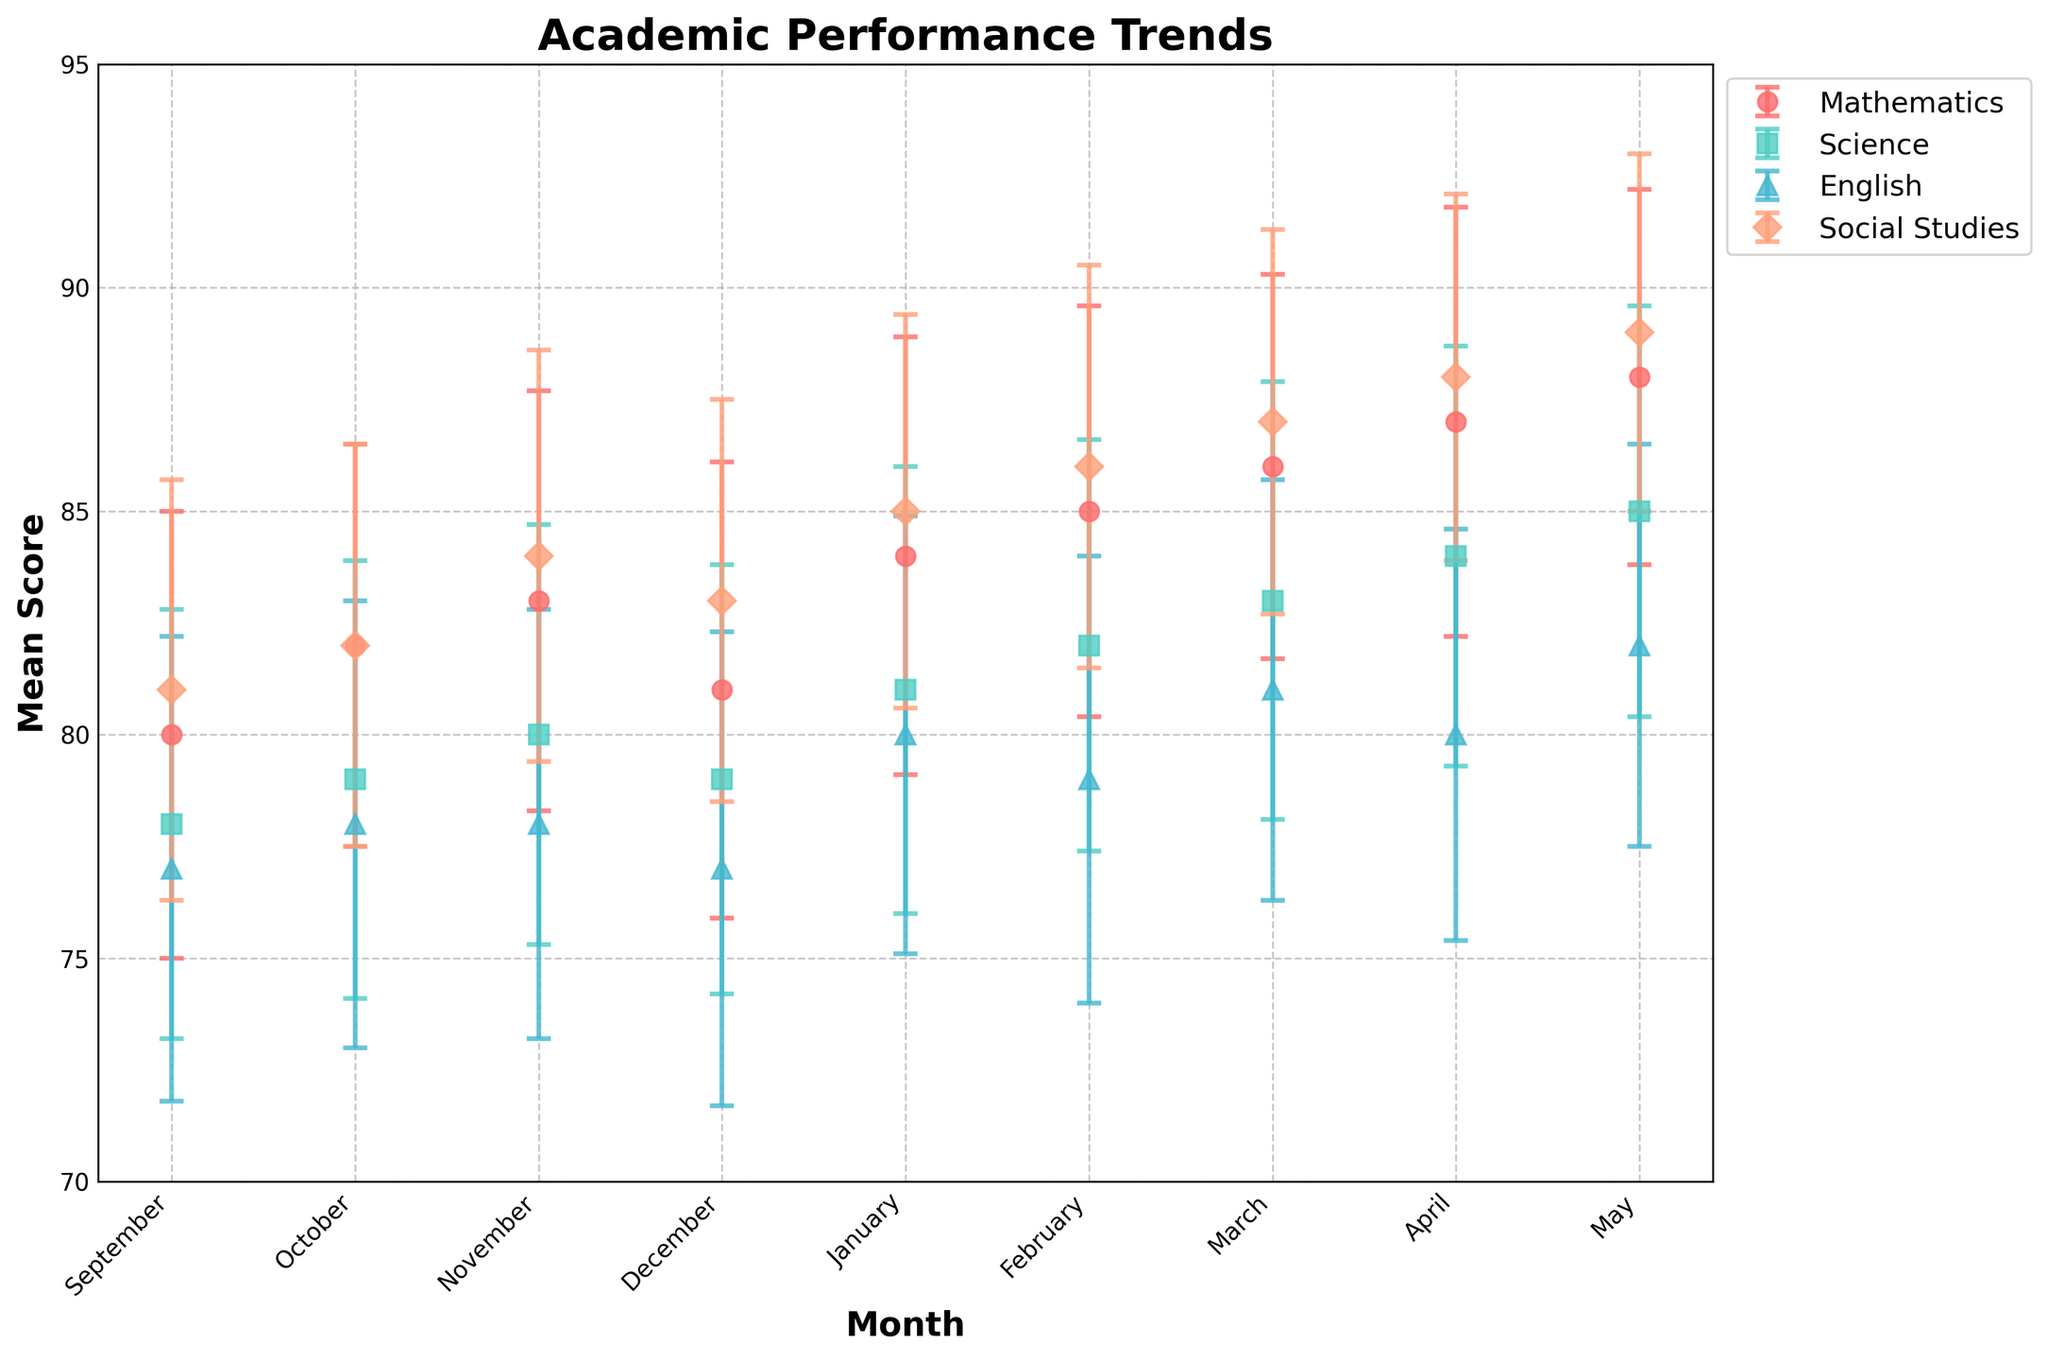What is the main title of the plot? The main title is written at the top center of the plot. It helps in providing an overview of what the plot is about.
Answer: Academic Performance Trends What subjects are represented in the plot? The subjects are shown in the legend of the plot, typically found on the right side of the plot. Each subject is indicated by a different marker and color.
Answer: Mathematics, Science, English, Social Studies In which month does Mathematics have the highest mean score? Look at the Mathematics line in the plot and find the month at which it reaches its peak value.
Answer: May How does the trend of Science scores compare to English scores over the months? Check the lines representing Science and English. Observe the direction and values of these lines across different months.
Answer: Both increase over time with minor variations, but Science consistently has slightly higher scores Which subject has the lowest mean score in September and what is it? Find the data points on the plot for September for each subject and identify the smallest value.
Answer: English, 77 By how much did the Mathematics score increase from January to May? Find the scores of Mathematics for January and May, then subtract the January score from the May score.
Answer: 4 points (88 - 84) During which month do all subjects show their lowest scores? Examine each line's starting point in September to see if any month has the lowest scores across all subjects.
Answer: September Which subject shows the least variability in scores over the year? Observe the lengths of the error bars for each subject; the shorter the error bars, the less variability.
Answer: Social Studies What pattern is observed in Social Studies scores from September to May? Look at the Social Studies line in the plot and describe how it changes month to month.
Answer: Scores consistently increase each month Which month has the highest variability in English scores, based on the error bars? Compare the error bars for English in each month, and identify the month where the error bar is the longest.
Answer: December 